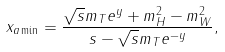<formula> <loc_0><loc_0><loc_500><loc_500>x _ { a \min } = \frac { \sqrt { s } m _ { T } e ^ { y } + m _ { H } ^ { 2 } - m _ { W } ^ { 2 } } { s - \sqrt { s } m _ { T } e ^ { - y } } ,</formula> 